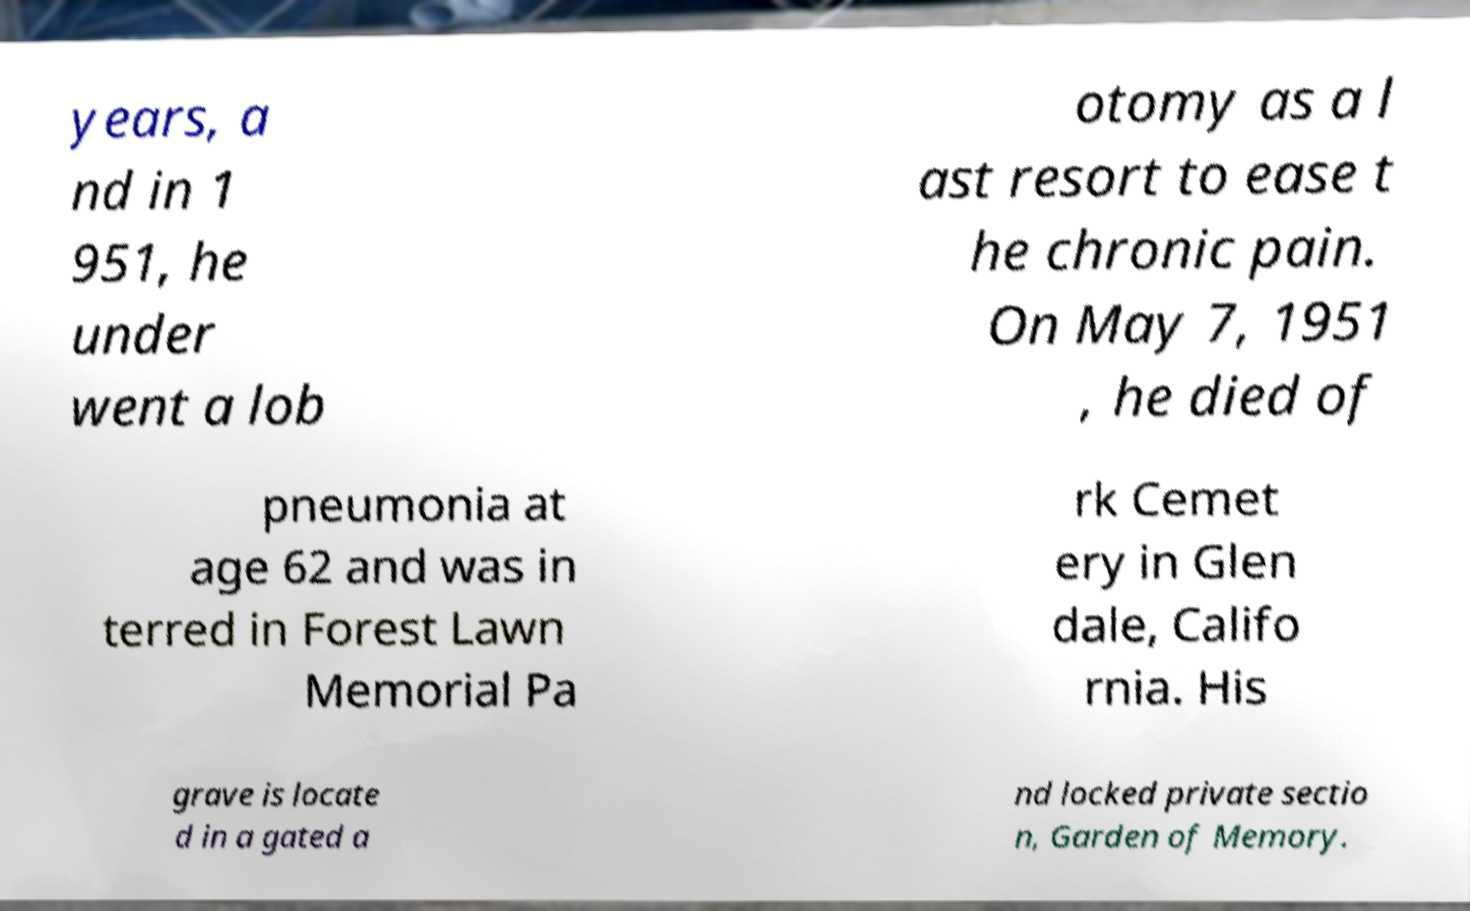Could you extract and type out the text from this image? years, a nd in 1 951, he under went a lob otomy as a l ast resort to ease t he chronic pain. On May 7, 1951 , he died of pneumonia at age 62 and was in terred in Forest Lawn Memorial Pa rk Cemet ery in Glen dale, Califo rnia. His grave is locate d in a gated a nd locked private sectio n, Garden of Memory. 